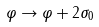Convert formula to latex. <formula><loc_0><loc_0><loc_500><loc_500>\varphi \rightarrow \varphi + 2 \sigma _ { 0 }</formula> 